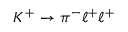<formula> <loc_0><loc_0><loc_500><loc_500>K ^ { + } \rightarrow \pi ^ { - } \ell ^ { + } \ell ^ { + }</formula> 